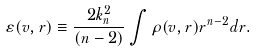<formula> <loc_0><loc_0><loc_500><loc_500>\varepsilon ( v , r ) \equiv \frac { 2 k _ { n } ^ { 2 } } { ( n - 2 ) } \int \rho ( v , r ) r ^ { n - 2 } d r .</formula> 